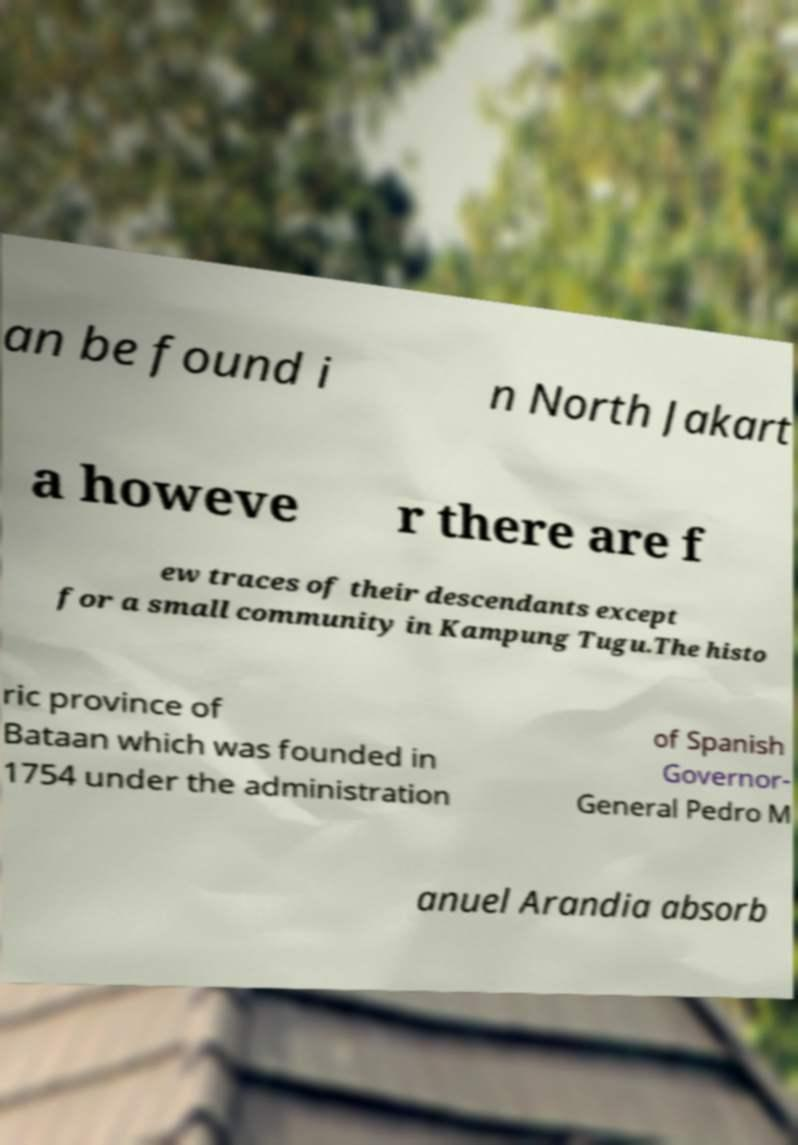Can you accurately transcribe the text from the provided image for me? an be found i n North Jakart a howeve r there are f ew traces of their descendants except for a small community in Kampung Tugu.The histo ric province of Bataan which was founded in 1754 under the administration of Spanish Governor- General Pedro M anuel Arandia absorb 